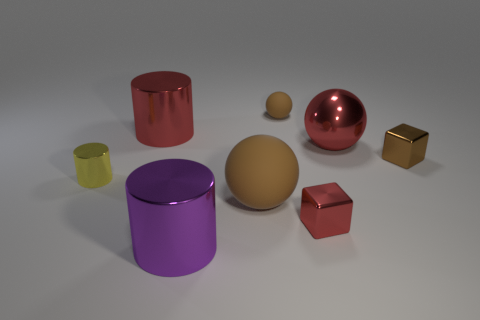Subtract all big brown balls. How many balls are left? 2 Add 2 small brown matte things. How many objects exist? 10 Subtract all red cubes. How many cubes are left? 1 Subtract 1 cubes. How many cubes are left? 1 Subtract all blue blocks. How many red spheres are left? 1 Subtract all purple spheres. Subtract all purple cubes. How many spheres are left? 3 Subtract all brown objects. Subtract all big metallic cylinders. How many objects are left? 3 Add 7 yellow shiny cylinders. How many yellow shiny cylinders are left? 8 Add 4 large purple cylinders. How many large purple cylinders exist? 5 Subtract 1 red cylinders. How many objects are left? 7 